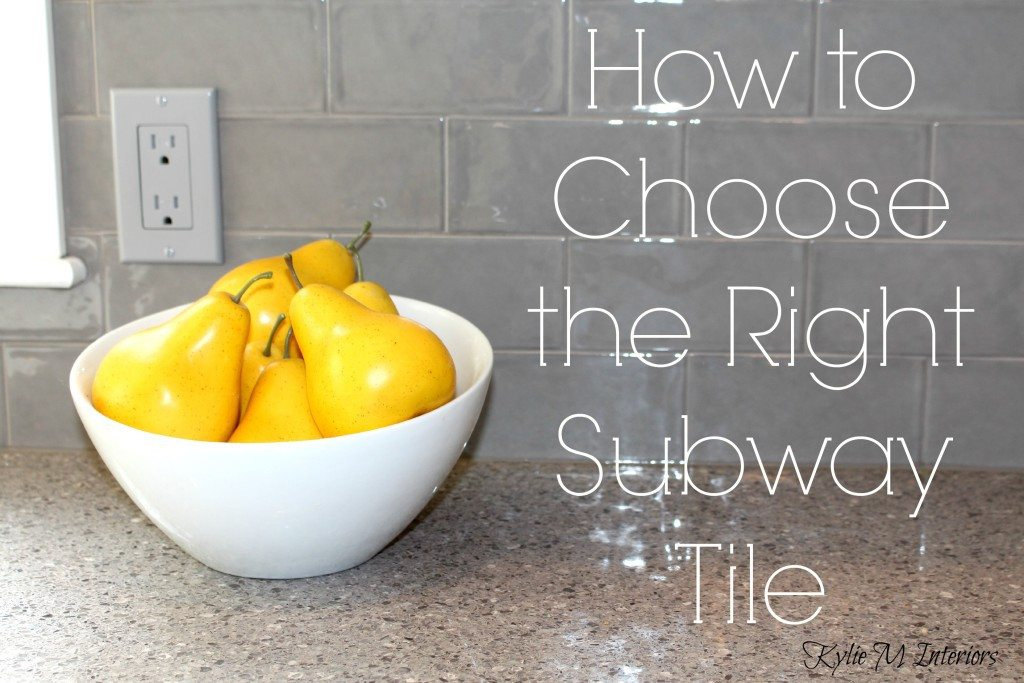How might the choice of countertop material complement the gray subway tiles in terms of maintenance and aesthetic appeal? The robust granite countertop visible in the image provides a splendid complement to the gray subway tiles. Granite is renowned for its durability and ease of maintenance, which harmonizes with the practical aspects of the glossy subway tiles. Aesthetically, the natural patterns and slightly darker shade of the granite create a subtle contrast with the smooth and uniform tiles, enhancing the kitchen's visual depth and sophistication. This combination not only ensures a kitchen that is easy to clean but also one that bears a cohesive and elegant design that remains appealing over time. 